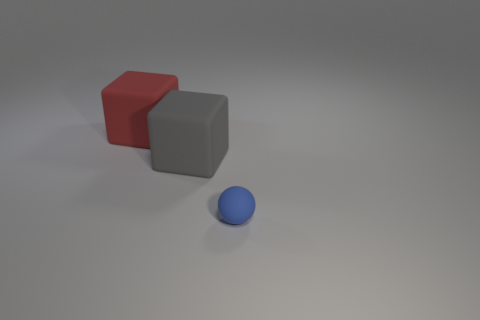Add 1 red matte objects. How many objects exist? 4 Subtract all blocks. How many objects are left? 1 Add 1 small matte things. How many small matte things exist? 2 Subtract 0 yellow blocks. How many objects are left? 3 Subtract all large red matte cubes. Subtract all large red metal objects. How many objects are left? 2 Add 1 large gray rubber cubes. How many large gray rubber cubes are left? 2 